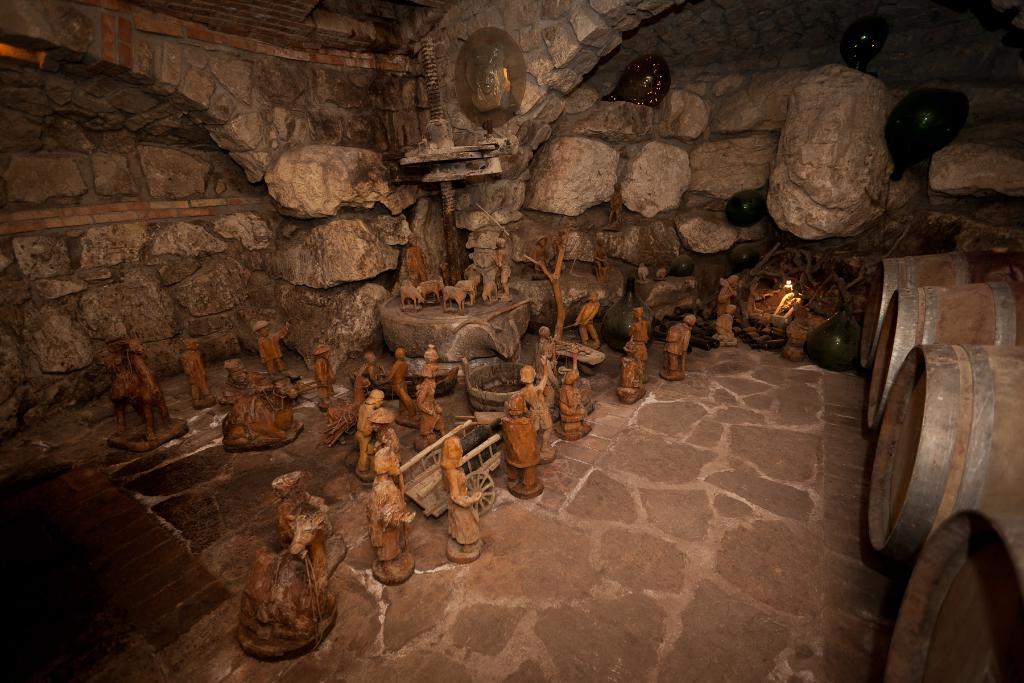How would you summarize this image in a sentence or two? In this image we can see many sculptures placed on the floor. In the background we can see walls and bins. 